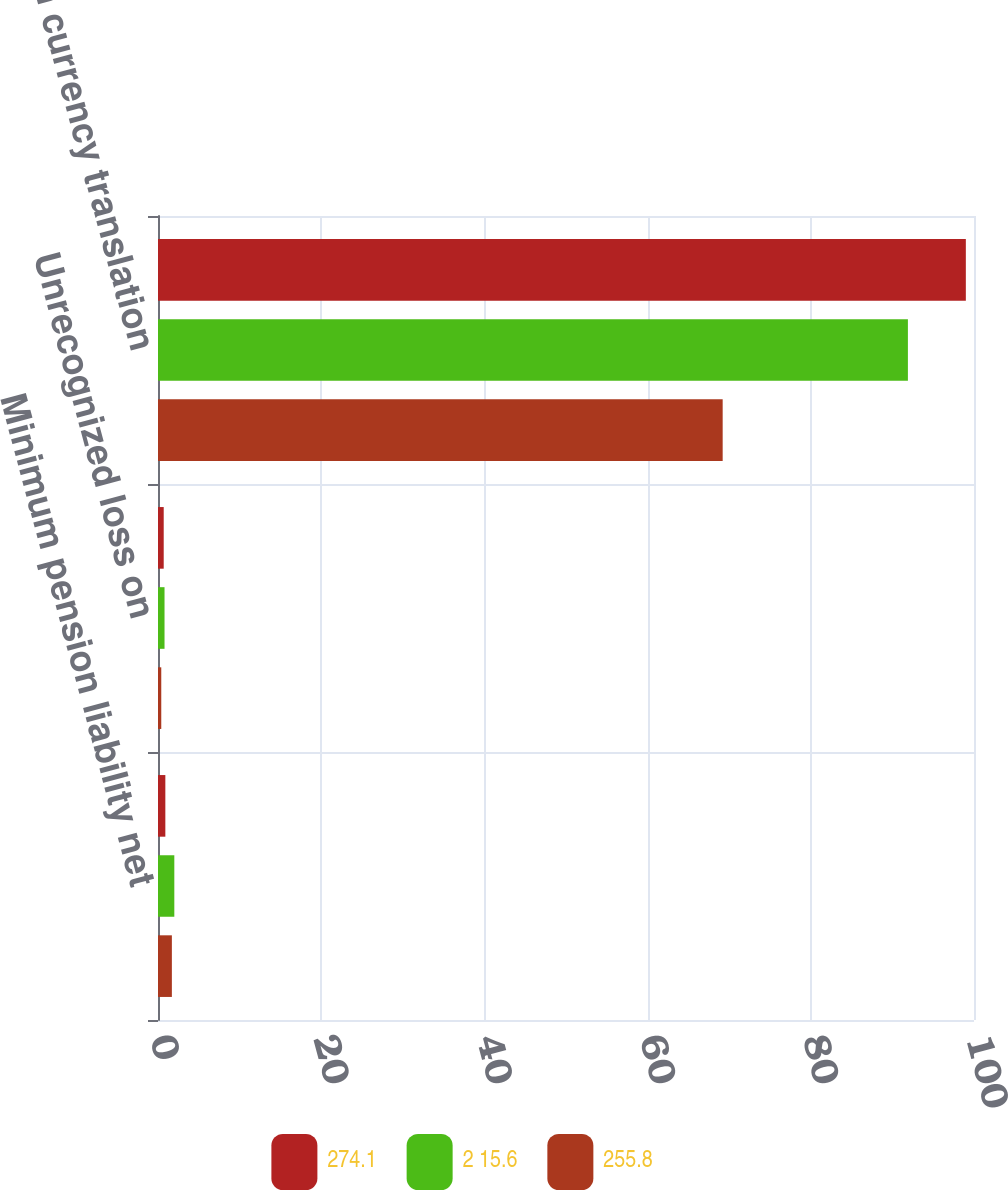Convert chart. <chart><loc_0><loc_0><loc_500><loc_500><stacked_bar_chart><ecel><fcel>Minimum pension liability net<fcel>Unrecognized loss on<fcel>Foreign currency translation<nl><fcel>274.1<fcel>0.9<fcel>0.7<fcel>99<nl><fcel>2 15.6<fcel>2<fcel>0.8<fcel>91.9<nl><fcel>255.8<fcel>1.7<fcel>0.4<fcel>69.2<nl></chart> 